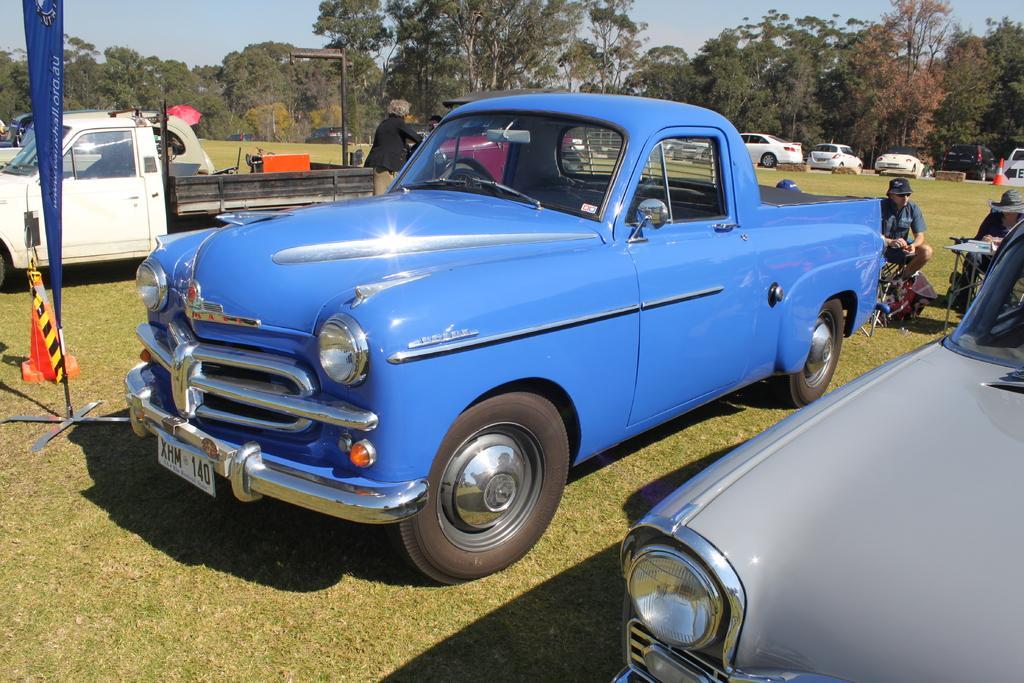Describe this image in one or two sentences. This picture is clicked outside. In the foreground we can see there are some vehicles parked on the ground and we can see the group of people. On the left there is a blue color banner on which the text is printed and there are some objects placed on the ground. In the background there is a sky, trees, pole and group of vehicles. 